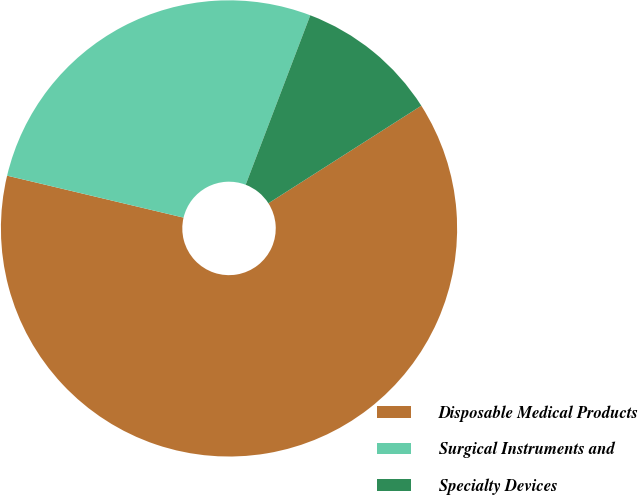<chart> <loc_0><loc_0><loc_500><loc_500><pie_chart><fcel>Disposable Medical Products<fcel>Surgical Instruments and<fcel>Specialty Devices<nl><fcel>62.75%<fcel>27.08%<fcel>10.16%<nl></chart> 